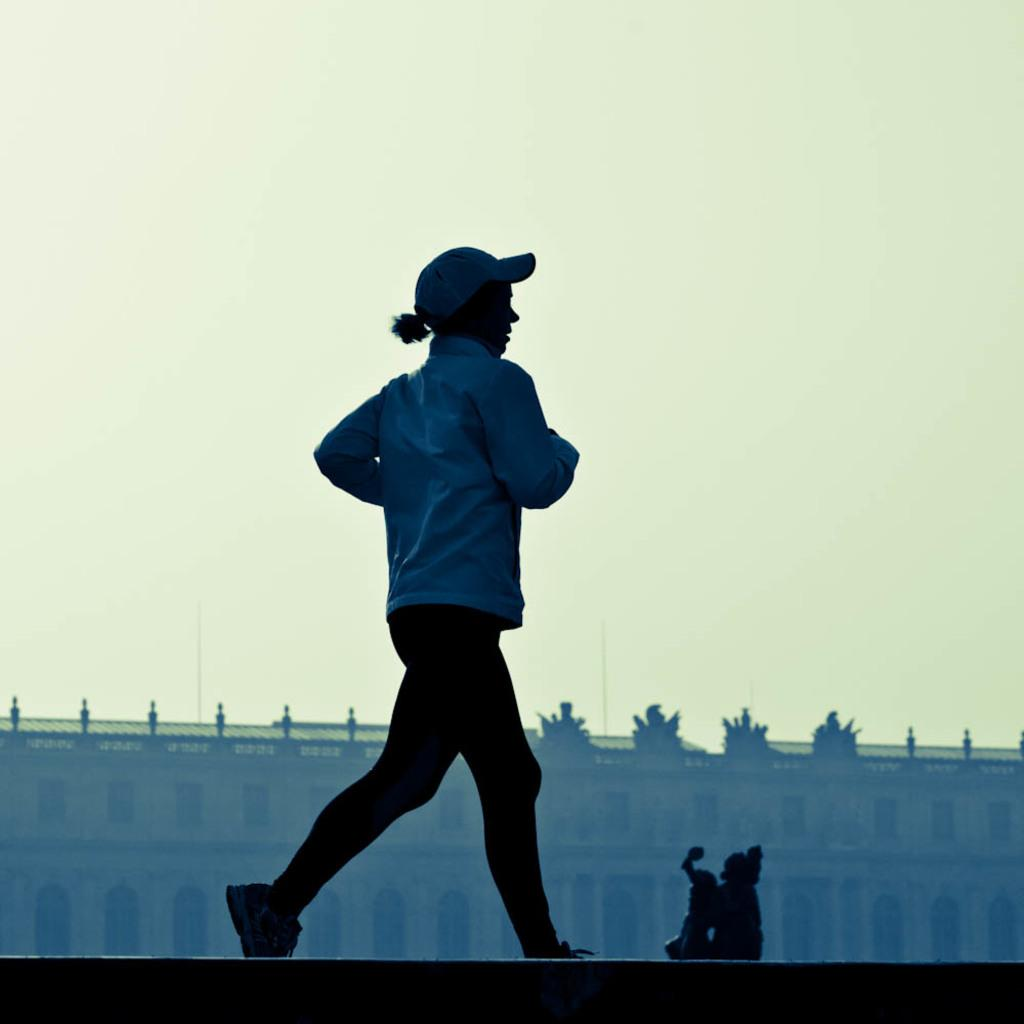What is the main subject of the image? The main subject of the image is a woman. What is the woman doing in the image? The woman is running in the image. What type of clothing is the woman wearing? The woman is wearing a jerkin, a cap, trousers, and shoes. What can be inferred about the medium of the image? The image appears to be a sculpture. What is visible in the background of the image? There is a wall and a building in the background of the image. Can you tell me how many buns are on the table in the image? There is no table or buns present in the image; it features a sculpture of a running woman. What type of hall is depicted in the image? There is no hall depicted in the image; it features a sculpture of a running woman. 